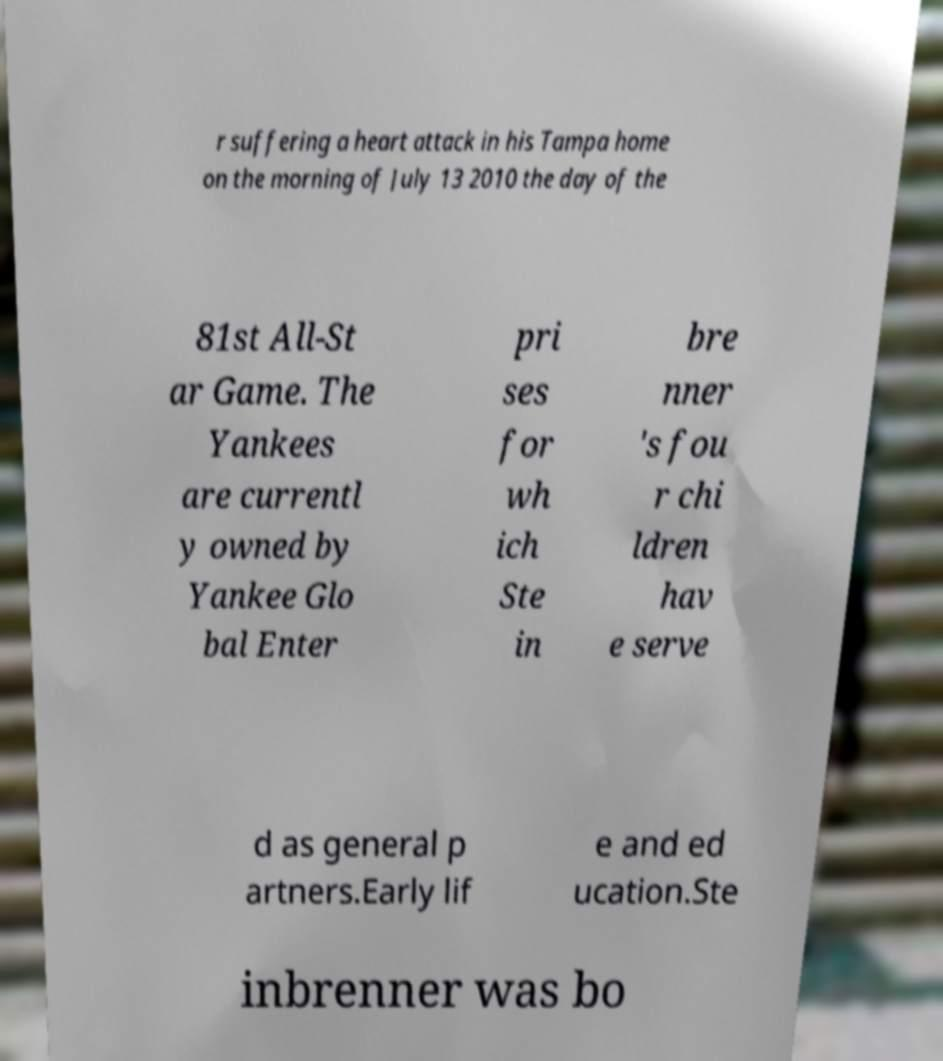Could you assist in decoding the text presented in this image and type it out clearly? r suffering a heart attack in his Tampa home on the morning of July 13 2010 the day of the 81st All-St ar Game. The Yankees are currentl y owned by Yankee Glo bal Enter pri ses for wh ich Ste in bre nner 's fou r chi ldren hav e serve d as general p artners.Early lif e and ed ucation.Ste inbrenner was bo 